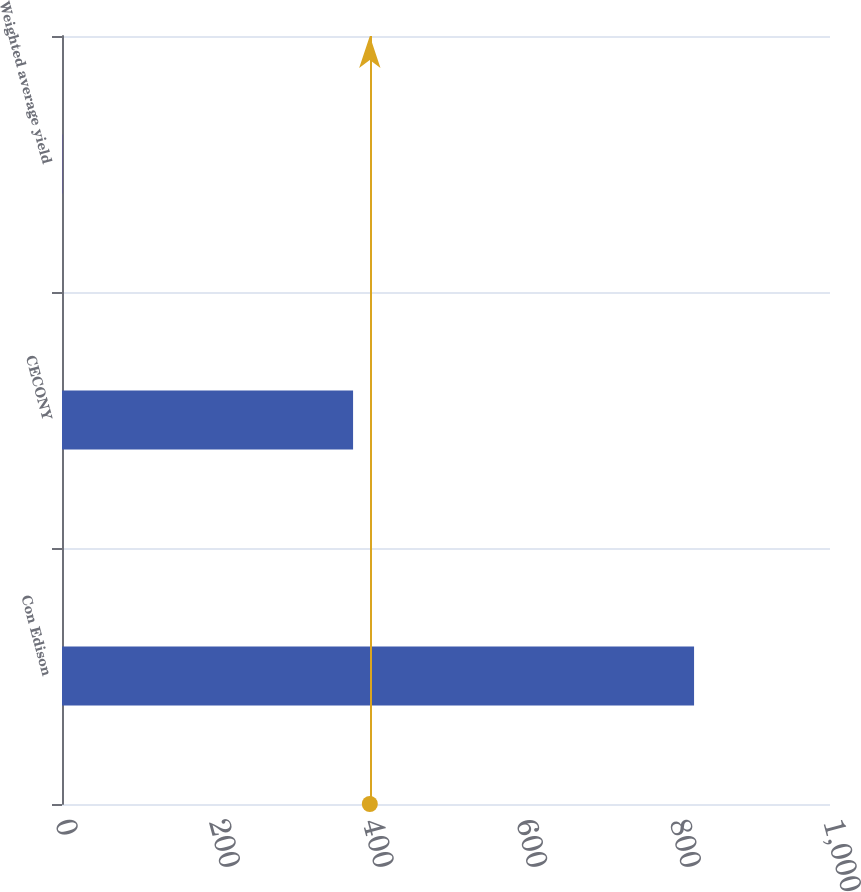Convert chart to OTSL. <chart><loc_0><loc_0><loc_500><loc_500><bar_chart><fcel>Con Edison<fcel>CECONY<fcel>Weighted average yield<nl><fcel>823<fcel>379<fcel>0.4<nl></chart> 